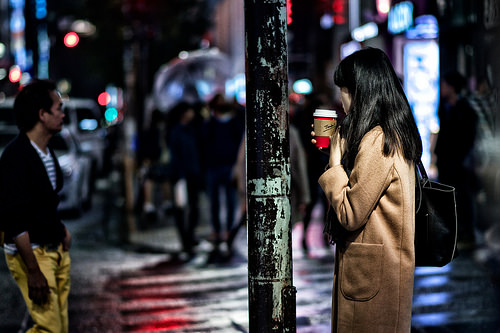<image>
Is there a coffee cup behind the street lamp? Yes. From this viewpoint, the coffee cup is positioned behind the street lamp, with the street lamp partially or fully occluding the coffee cup. 